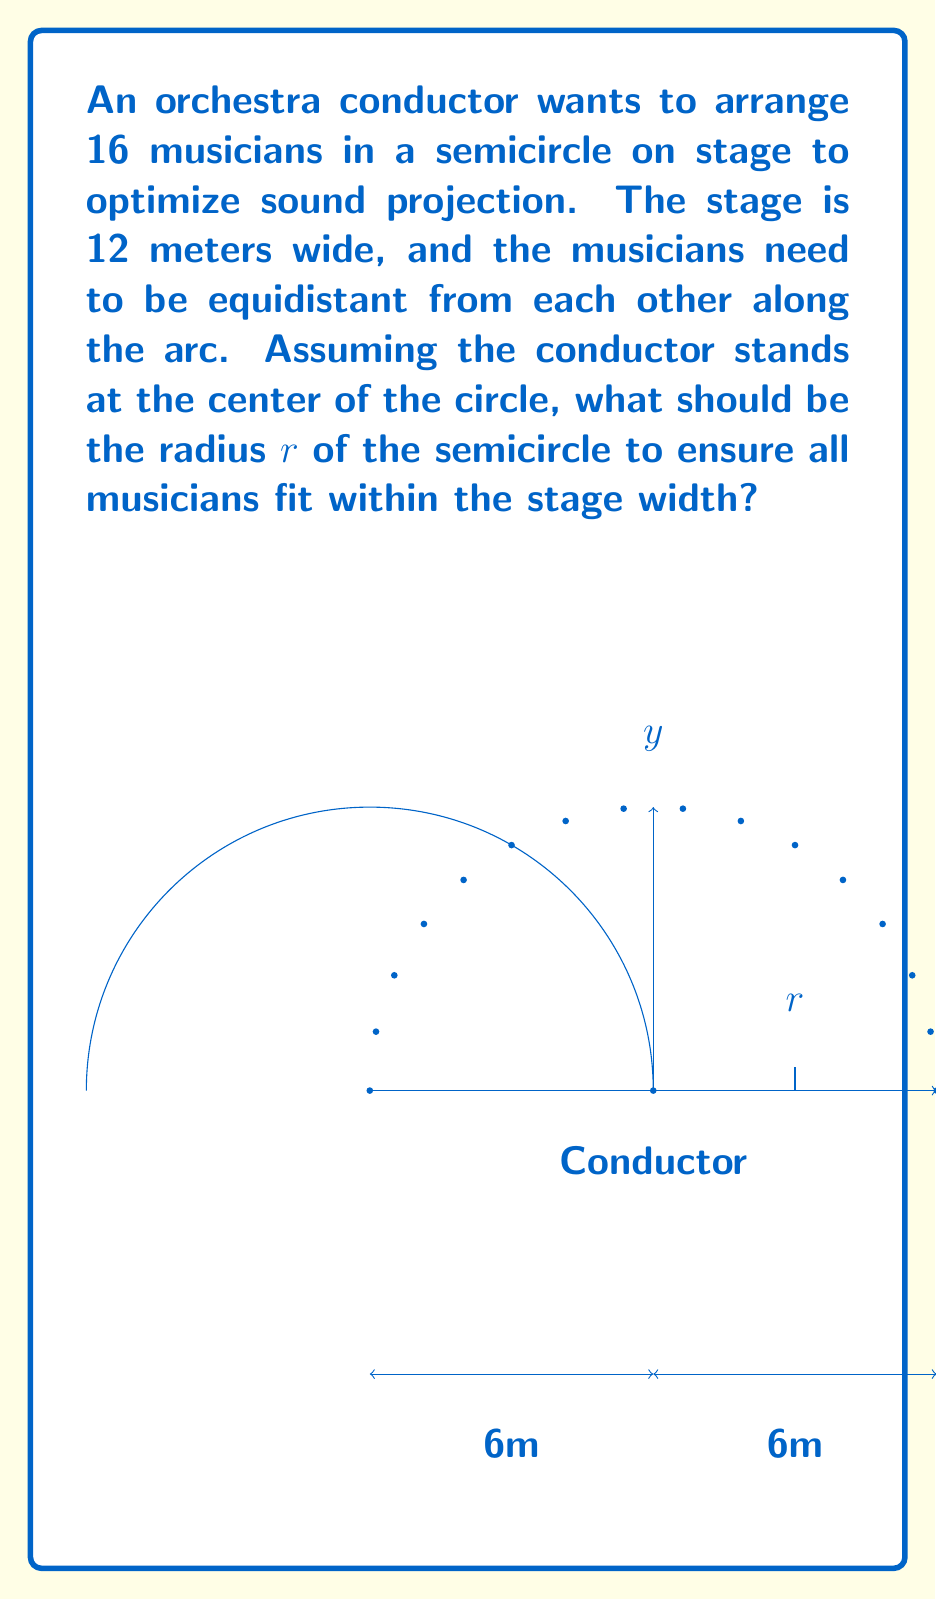Solve this math problem. Let's approach this step-by-step:

1) In a semicircle, the arc length $L$ is related to the radius $r$ by the formula:
   $$L = \pi r$$

2) We need to fit 16 musicians equidistantly along this arc. If we divide the arc into 15 equal segments (there are 15 spaces between 16 musicians), each segment will have a length of:
   $$\text{segment length} = \frac{L}{15} = \frac{\pi r}{15}$$

3) The straight-line distance between the first and last musician (the chord of the semicircle) needs to be 12 meters. In a semicircle, this chord is equal to the diameter, which is twice the radius:
   $$2r = 12$$
   $$r = 6$$

4) Now we need to check if this radius allows for enough space between musicians. The arc length with $r = 6$ is:
   $$L = \pi r = \pi \cdot 6 \approx 18.85 \text{ meters}$$

5) The space between each musician would be:
   $$\text{space} = \frac{18.85}{15} \approx 1.26 \text{ meters}$$

6) This spacing is reasonable for an orchestra, so our calculated radius of 6 meters is optimal.
Answer: $r = 6$ meters 